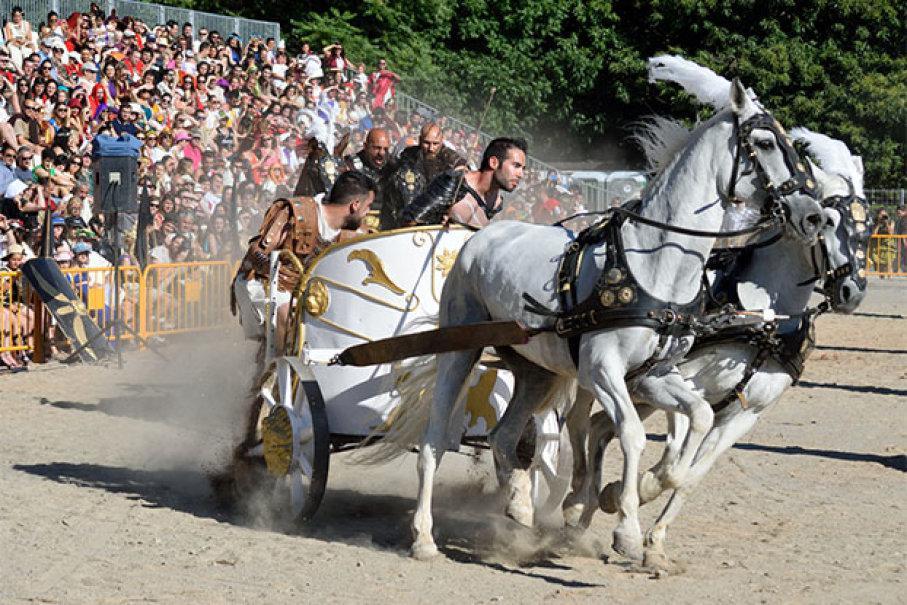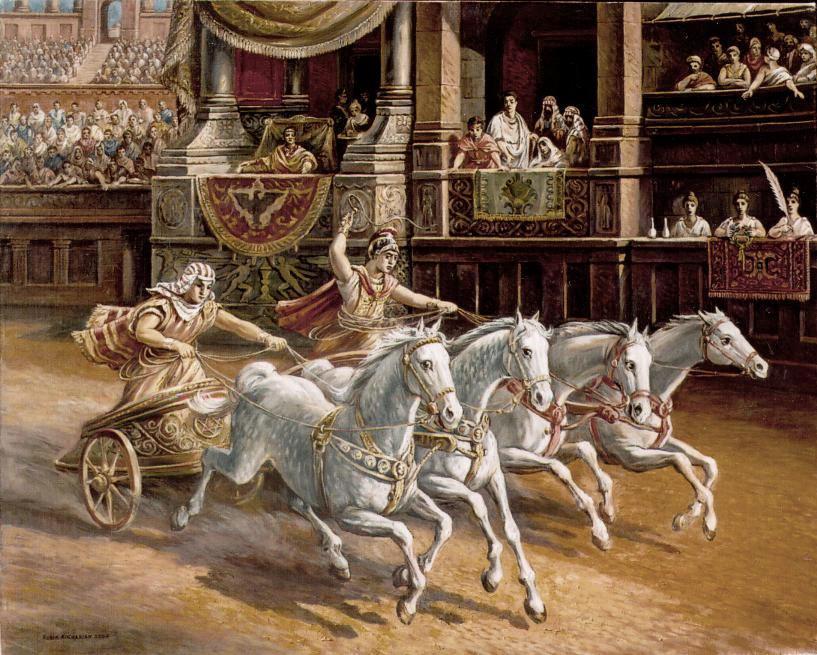The first image is the image on the left, the second image is the image on the right. For the images shown, is this caption "There are brown horses shown in at least one of the images." true? Answer yes or no. No. The first image is the image on the left, the second image is the image on the right. Evaluate the accuracy of this statement regarding the images: "At least one image shows a cart pulled by four horses.". Is it true? Answer yes or no. Yes. 